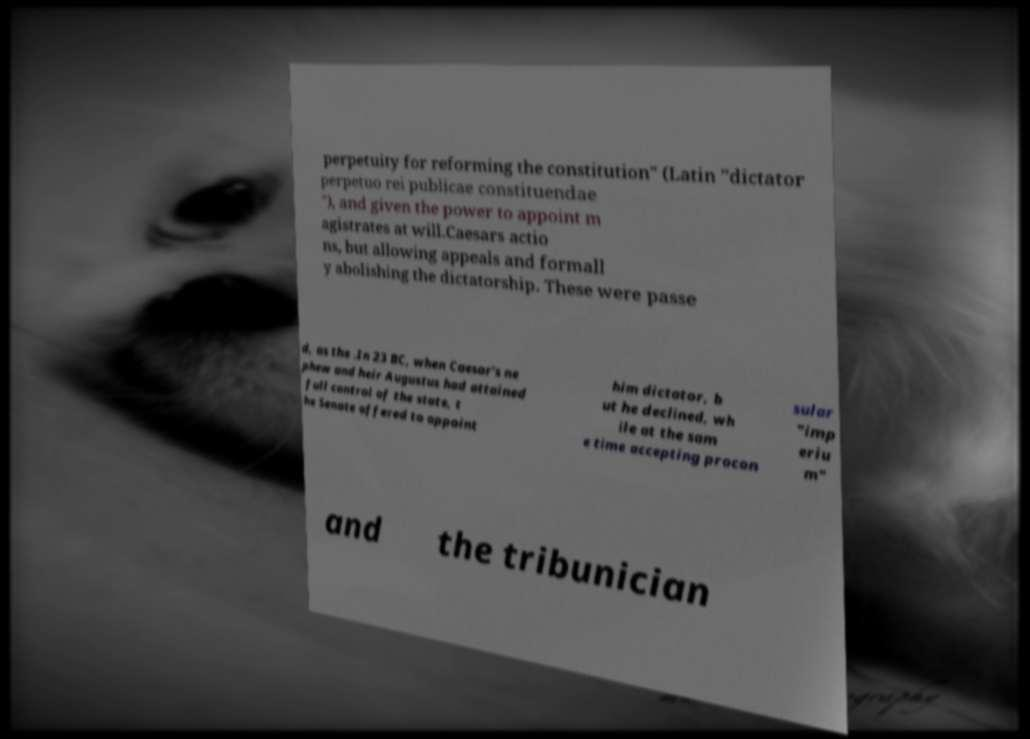Could you extract and type out the text from this image? perpetuity for reforming the constitution" (Latin "dictator perpetuo rei publicae constituendae "), and given the power to appoint m agistrates at will.Caesars actio ns, but allowing appeals and formall y abolishing the dictatorship. These were passe d, as the .In 23 BC, when Caesar's ne phew and heir Augustus had attained full control of the state, t he Senate offered to appoint him dictator, b ut he declined, wh ile at the sam e time accepting procon sular "imp eriu m" and the tribunician 